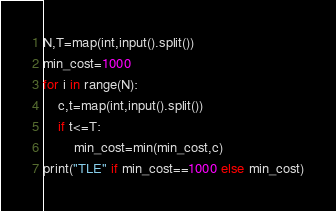<code> <loc_0><loc_0><loc_500><loc_500><_Python_>N,T=map(int,input().split())
min_cost=1000
for i in range(N):
    c,t=map(int,input().split())
    if t<=T:
        min_cost=min(min_cost,c)
print("TLE" if min_cost==1000 else min_cost)</code> 